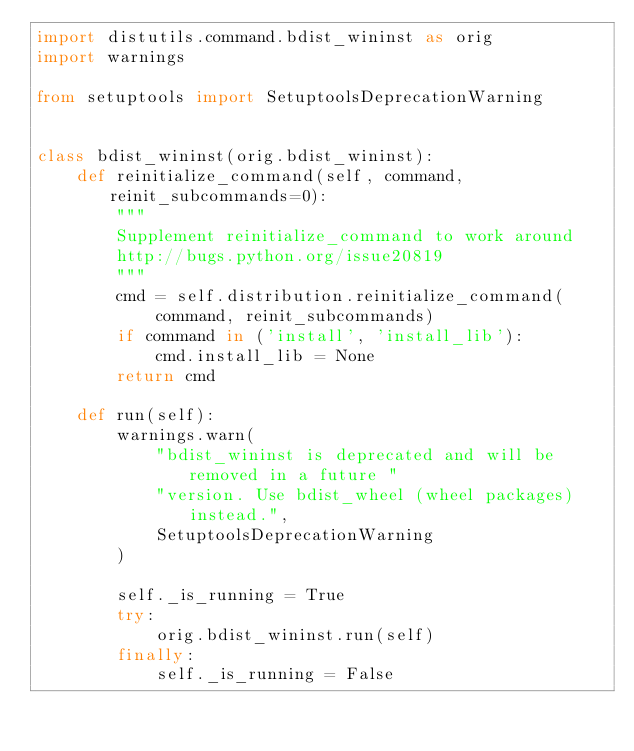Convert code to text. <code><loc_0><loc_0><loc_500><loc_500><_Python_>import distutils.command.bdist_wininst as orig
import warnings

from setuptools import SetuptoolsDeprecationWarning


class bdist_wininst(orig.bdist_wininst):
    def reinitialize_command(self, command, reinit_subcommands=0):
        """
        Supplement reinitialize_command to work around
        http://bugs.python.org/issue20819
        """
        cmd = self.distribution.reinitialize_command(
            command, reinit_subcommands)
        if command in ('install', 'install_lib'):
            cmd.install_lib = None
        return cmd

    def run(self):
        warnings.warn(
            "bdist_wininst is deprecated and will be removed in a future "
            "version. Use bdist_wheel (wheel packages) instead.",
            SetuptoolsDeprecationWarning
        )

        self._is_running = True
        try:
            orig.bdist_wininst.run(self)
        finally:
            self._is_running = False
</code> 